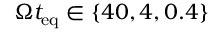<formula> <loc_0><loc_0><loc_500><loc_500>\Omega t _ { e q } \in \{ 4 0 , 4 , 0 . 4 \}</formula> 